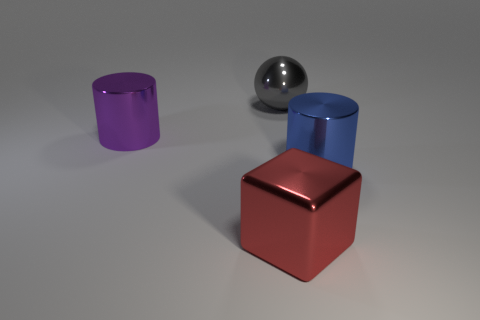Subtract all blue cylinders. How many cylinders are left? 1 Subtract all cubes. How many objects are left? 3 Subtract 1 balls. How many balls are left? 0 Subtract all cyan balls. Subtract all cyan blocks. How many balls are left? 1 Subtract all red cubes. How many purple cylinders are left? 1 Subtract all big balls. Subtract all big matte cubes. How many objects are left? 3 Add 1 gray balls. How many gray balls are left? 2 Add 4 large purple cylinders. How many large purple cylinders exist? 5 Add 1 large yellow shiny objects. How many objects exist? 5 Subtract 0 cyan spheres. How many objects are left? 4 